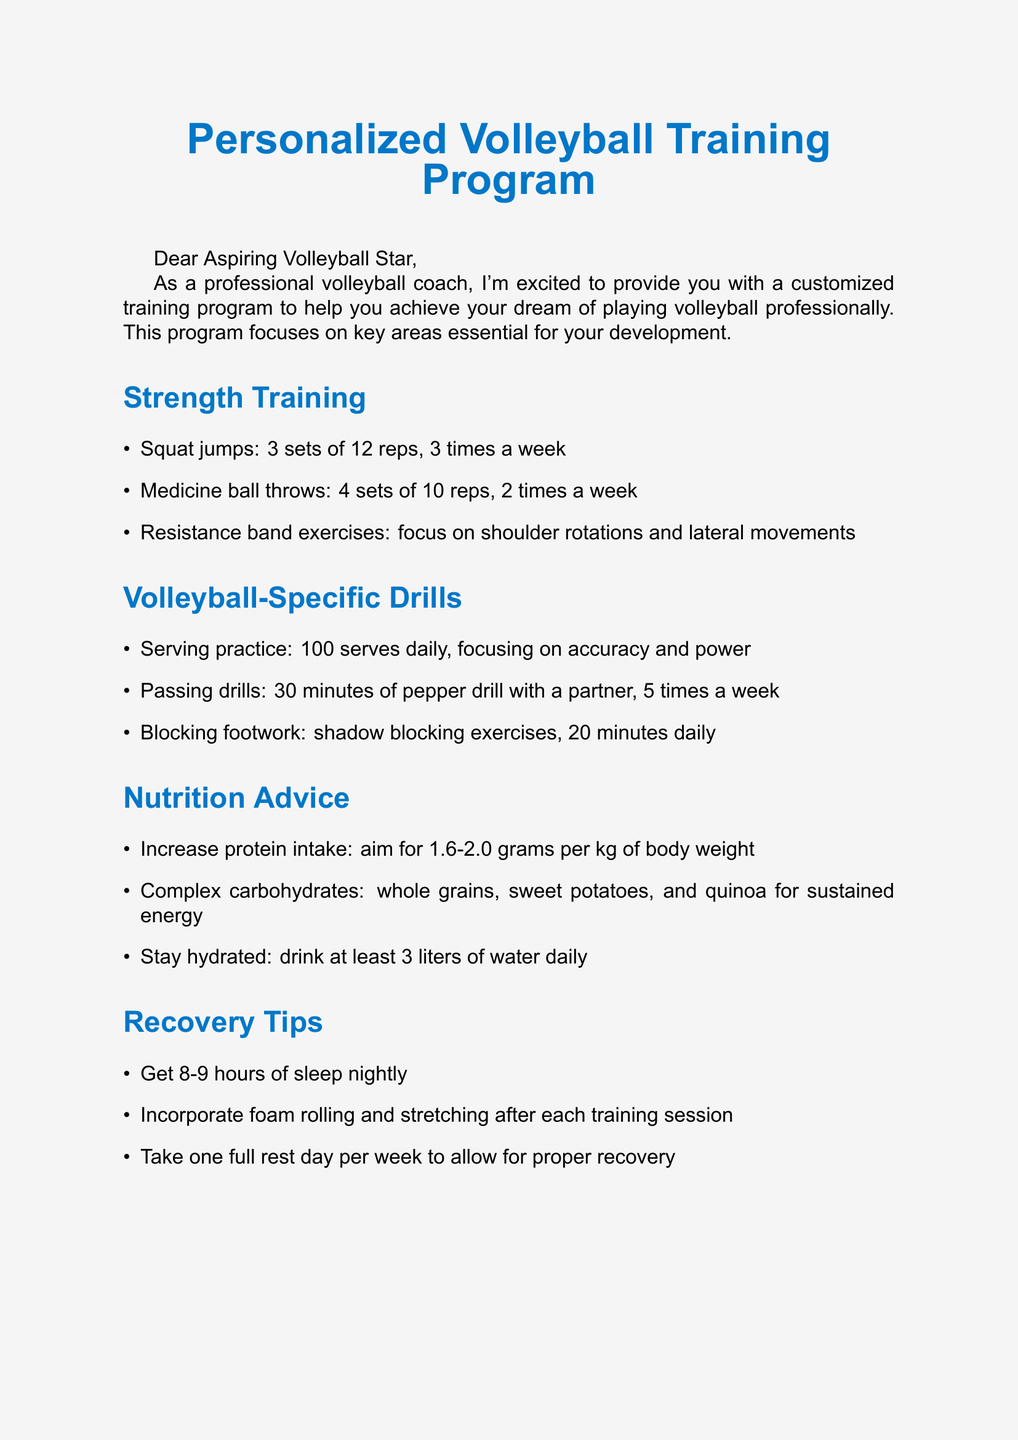What are the strength exercises recommended? The document lists several strength exercises such as squat jumps, medicine ball throws, and resistance band exercises.
Answer: Squat jumps, medicine ball throws, resistance band exercises How many sets and reps for squat jumps? The document specifies the sets and reps for squat jumps as part of the strength training section.
Answer: 3 sets of 12 reps What is the daily hydration recommendation? The document provides specific hydration advice referring to how much water one should drink daily.
Answer: 3 liters What role does protein play in nutrition? The document states the recommended protein intake for athletes and its significance related to body weight.
Answer: 1.6-2.0 grams per kg of body weight How many serves should one practice daily? The document highlights a specific daily drill for improving serving skills.
Answer: 100 serves daily What is the importance of a highlight reel? The career guidance section suggests creating a highlight reel for a particular purpose.
Answer: For college recruiters How often should foam rolling and stretching be incorporated? The recovery tips section mentions specific practices post-training sessions.
Answer: After each training session What should be done on a rest day? The document advises on the need for recovery and what to do during rest days.
Answer: Take one full rest day What is the overall theme of the document? The document's content is centered around providing tailored advice for a specific audience of volleyball players.
Answer: Personalized training program 